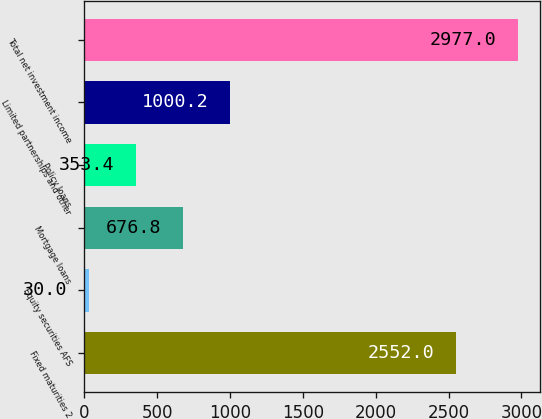Convert chart. <chart><loc_0><loc_0><loc_500><loc_500><bar_chart><fcel>Fixed maturities 2<fcel>Equity securities AFS<fcel>Mortgage loans<fcel>Policy loans<fcel>Limited partnerships and other<fcel>Total net investment income<nl><fcel>2552<fcel>30<fcel>676.8<fcel>353.4<fcel>1000.2<fcel>2977<nl></chart> 